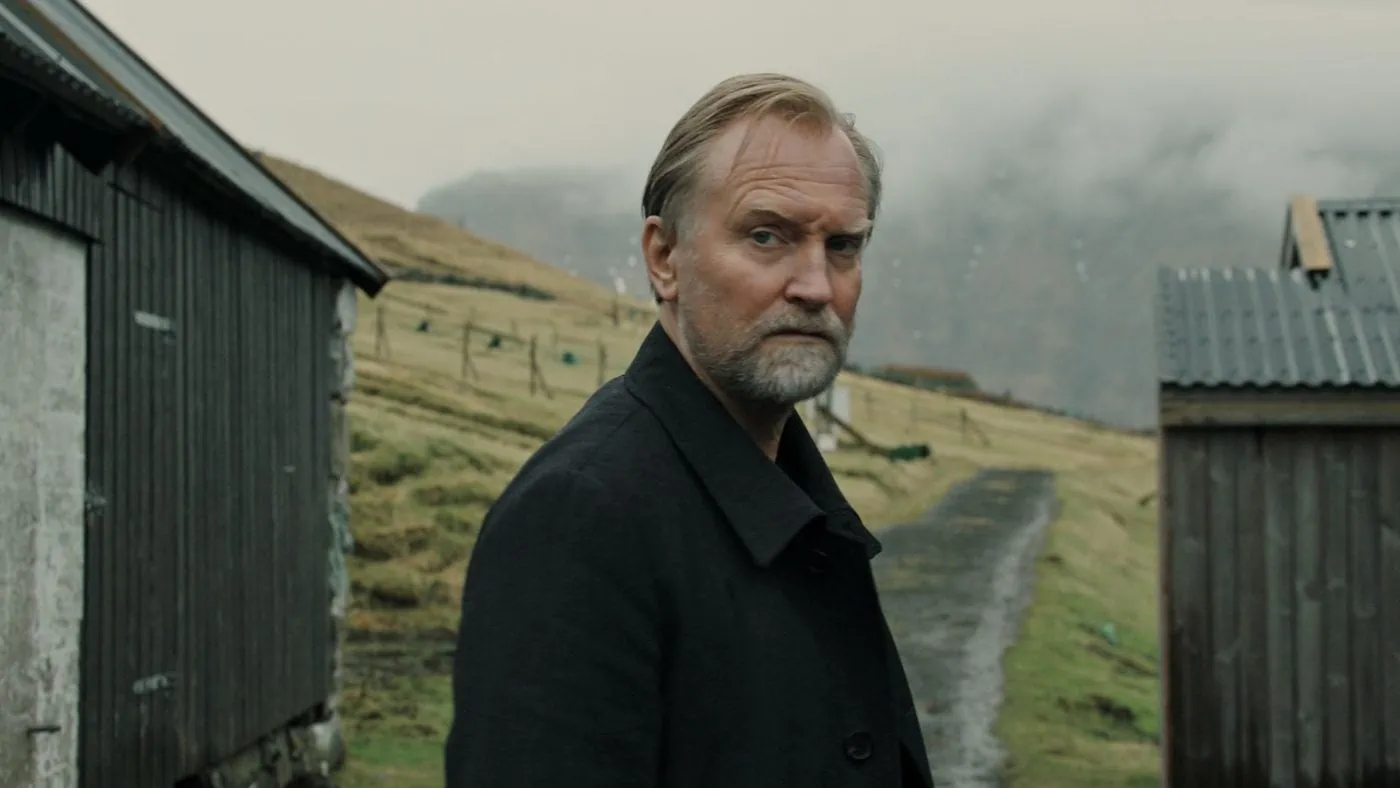What story could this image be telling? This image could be illustrating the story of a man who has returned to his childhood home after many years. The rustic buildings and the familiar walking path may evoke memories of a simpler time, one filled with both joy and sorrow. His serious expression hints at a deeper narrative, perhaps reflecting on choices made, opportunities lost, or the inexorable passage of time. The overcast sky might symbolize a sense of melancholy or wistfulness, enhancing the overall atmosphere of introspection. 